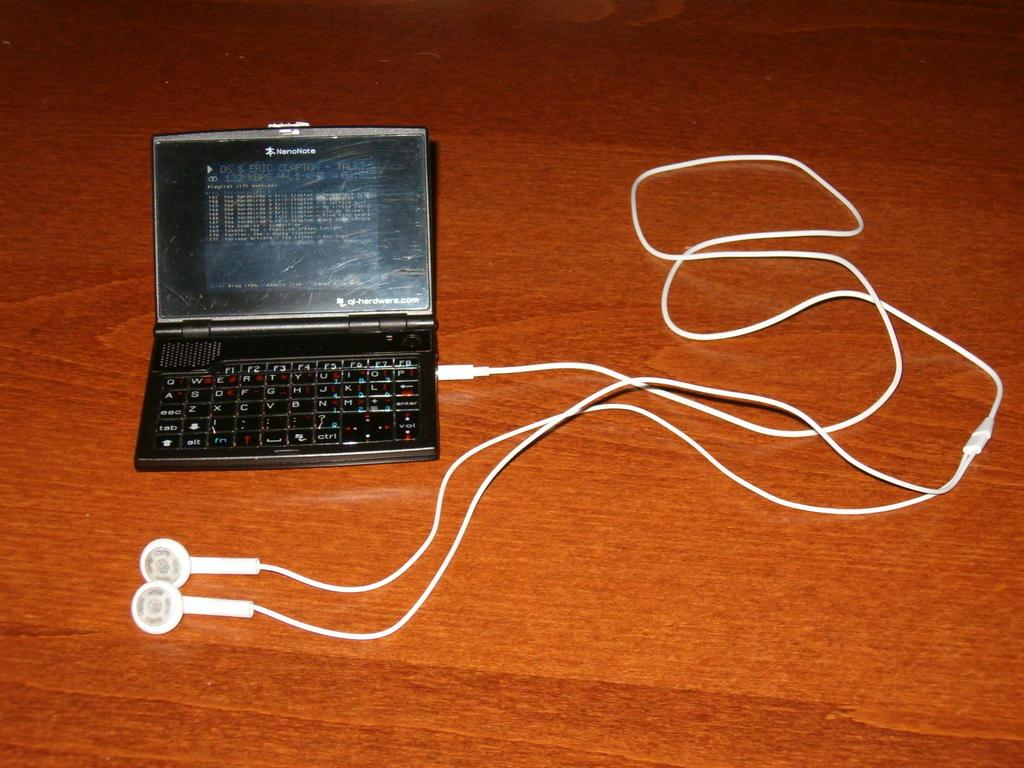<image>
Describe the image concisely. The item shown has a keyboard with the keys esc, tab and alt shown along with various others. 